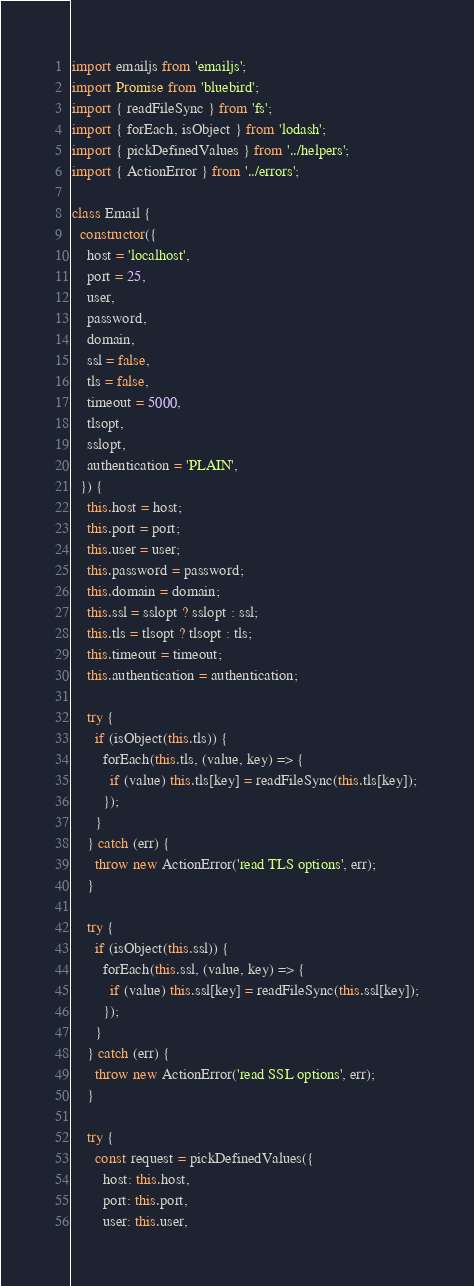Convert code to text. <code><loc_0><loc_0><loc_500><loc_500><_JavaScript_>import emailjs from 'emailjs';
import Promise from 'bluebird';
import { readFileSync } from 'fs';
import { forEach, isObject } from 'lodash';
import { pickDefinedValues } from '../helpers';
import { ActionError } from '../errors';

class Email {
  constructor({
    host = 'localhost',
    port = 25,
    user,
    password,
    domain,
    ssl = false,
    tls = false,
    timeout = 5000,
    tlsopt,
    sslopt,
    authentication = 'PLAIN',
  }) {
    this.host = host;
    this.port = port;
    this.user = user;
    this.password = password;
    this.domain = domain;
    this.ssl = sslopt ? sslopt : ssl;
    this.tls = tlsopt ? tlsopt : tls;
    this.timeout = timeout;
    this.authentication = authentication;

    try {
      if (isObject(this.tls)) {
        forEach(this.tls, (value, key) => {
          if (value) this.tls[key] = readFileSync(this.tls[key]);
        });
      }
    } catch (err) {
      throw new ActionError('read TLS options', err);
    }

    try {
      if (isObject(this.ssl)) {
        forEach(this.ssl, (value, key) => {
          if (value) this.ssl[key] = readFileSync(this.ssl[key]);
        });
      }
    } catch (err) {
      throw new ActionError('read SSL options', err);
    }

    try {
      const request = pickDefinedValues({
        host: this.host,
        port: this.port,
        user: this.user,</code> 